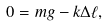<formula> <loc_0><loc_0><loc_500><loc_500>0 = m g - k \Delta \ell ,</formula> 